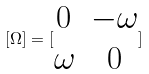Convert formula to latex. <formula><loc_0><loc_0><loc_500><loc_500>[ \Omega ] = [ \begin{matrix} 0 & - \omega \\ \omega & 0 \end{matrix} ]</formula> 